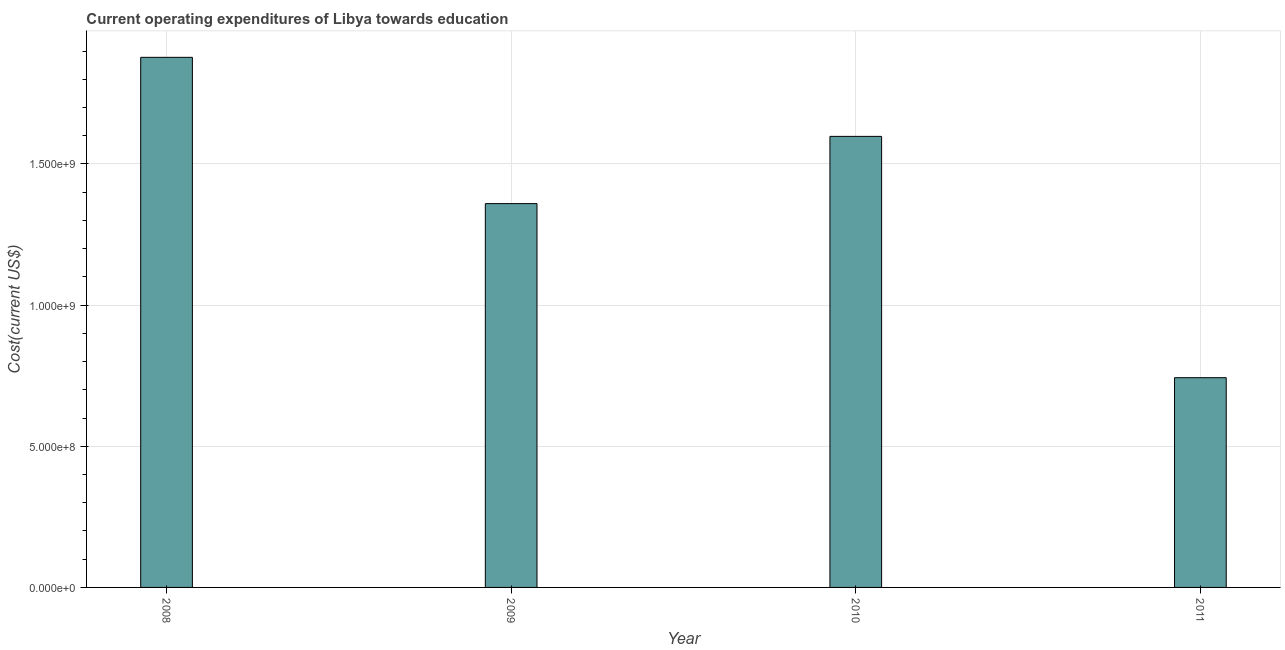Does the graph contain grids?
Offer a terse response. Yes. What is the title of the graph?
Offer a very short reply. Current operating expenditures of Libya towards education. What is the label or title of the X-axis?
Offer a very short reply. Year. What is the label or title of the Y-axis?
Keep it short and to the point. Cost(current US$). What is the education expenditure in 2009?
Provide a succinct answer. 1.36e+09. Across all years, what is the maximum education expenditure?
Ensure brevity in your answer.  1.88e+09. Across all years, what is the minimum education expenditure?
Ensure brevity in your answer.  7.43e+08. What is the sum of the education expenditure?
Make the answer very short. 5.58e+09. What is the difference between the education expenditure in 2008 and 2009?
Your answer should be compact. 5.18e+08. What is the average education expenditure per year?
Make the answer very short. 1.39e+09. What is the median education expenditure?
Provide a short and direct response. 1.48e+09. In how many years, is the education expenditure greater than 1800000000 US$?
Provide a succinct answer. 1. What is the ratio of the education expenditure in 2008 to that in 2009?
Ensure brevity in your answer.  1.38. Is the difference between the education expenditure in 2009 and 2010 greater than the difference between any two years?
Ensure brevity in your answer.  No. What is the difference between the highest and the second highest education expenditure?
Ensure brevity in your answer.  2.80e+08. What is the difference between the highest and the lowest education expenditure?
Give a very brief answer. 1.13e+09. In how many years, is the education expenditure greater than the average education expenditure taken over all years?
Make the answer very short. 2. What is the Cost(current US$) in 2008?
Make the answer very short. 1.88e+09. What is the Cost(current US$) in 2009?
Offer a very short reply. 1.36e+09. What is the Cost(current US$) of 2010?
Offer a very short reply. 1.60e+09. What is the Cost(current US$) in 2011?
Provide a short and direct response. 7.43e+08. What is the difference between the Cost(current US$) in 2008 and 2009?
Offer a terse response. 5.18e+08. What is the difference between the Cost(current US$) in 2008 and 2010?
Ensure brevity in your answer.  2.80e+08. What is the difference between the Cost(current US$) in 2008 and 2011?
Keep it short and to the point. 1.13e+09. What is the difference between the Cost(current US$) in 2009 and 2010?
Provide a succinct answer. -2.38e+08. What is the difference between the Cost(current US$) in 2009 and 2011?
Ensure brevity in your answer.  6.17e+08. What is the difference between the Cost(current US$) in 2010 and 2011?
Ensure brevity in your answer.  8.55e+08. What is the ratio of the Cost(current US$) in 2008 to that in 2009?
Offer a very short reply. 1.38. What is the ratio of the Cost(current US$) in 2008 to that in 2010?
Ensure brevity in your answer.  1.18. What is the ratio of the Cost(current US$) in 2008 to that in 2011?
Ensure brevity in your answer.  2.53. What is the ratio of the Cost(current US$) in 2009 to that in 2010?
Your response must be concise. 0.85. What is the ratio of the Cost(current US$) in 2009 to that in 2011?
Make the answer very short. 1.83. What is the ratio of the Cost(current US$) in 2010 to that in 2011?
Provide a succinct answer. 2.15. 